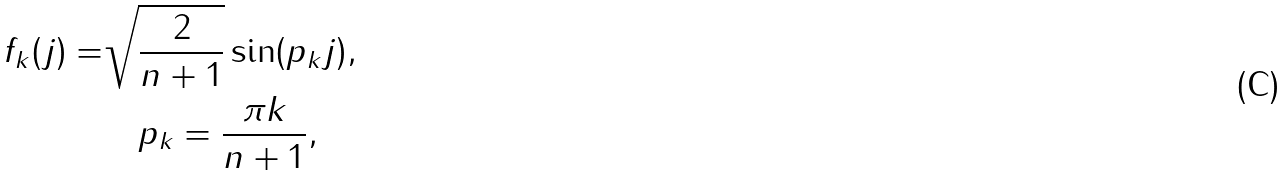Convert formula to latex. <formula><loc_0><loc_0><loc_500><loc_500>f _ { k } ( j ) = & \sqrt { \frac { 2 } { n + 1 } } \sin ( p _ { k } j ) , \\ & \quad p _ { k } = \frac { \pi k } { n + 1 } ,</formula> 